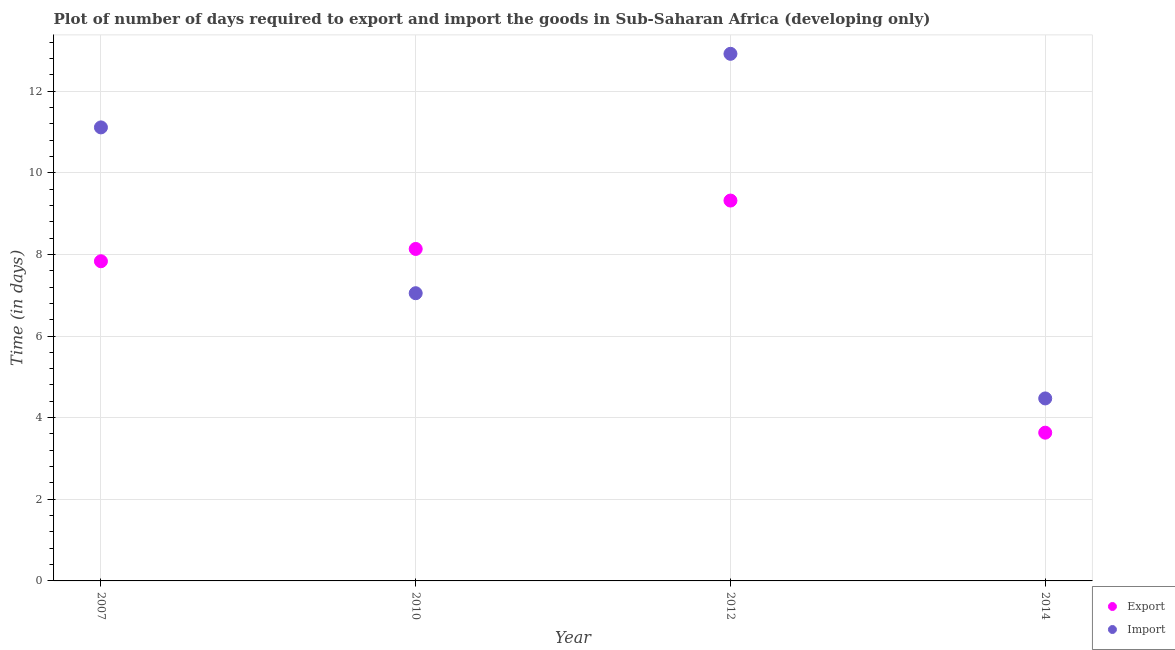Is the number of dotlines equal to the number of legend labels?
Ensure brevity in your answer.  Yes. What is the time required to import in 2007?
Ensure brevity in your answer.  11.11. Across all years, what is the maximum time required to export?
Your response must be concise. 9.32. Across all years, what is the minimum time required to export?
Give a very brief answer. 3.63. In which year was the time required to export minimum?
Make the answer very short. 2014. What is the total time required to export in the graph?
Make the answer very short. 28.91. What is the difference between the time required to import in 2012 and that in 2014?
Provide a short and direct response. 8.44. What is the difference between the time required to import in 2014 and the time required to export in 2012?
Give a very brief answer. -4.85. What is the average time required to import per year?
Offer a very short reply. 8.89. In the year 2012, what is the difference between the time required to import and time required to export?
Provide a succinct answer. 3.59. What is the ratio of the time required to export in 2010 to that in 2012?
Make the answer very short. 0.87. Is the time required to import in 2007 less than that in 2014?
Ensure brevity in your answer.  No. What is the difference between the highest and the second highest time required to import?
Offer a very short reply. 1.8. What is the difference between the highest and the lowest time required to import?
Ensure brevity in your answer.  8.44. Is the time required to import strictly greater than the time required to export over the years?
Offer a terse response. No. How many dotlines are there?
Provide a succinct answer. 2. How many years are there in the graph?
Your response must be concise. 4. Are the values on the major ticks of Y-axis written in scientific E-notation?
Offer a terse response. No. Does the graph contain any zero values?
Keep it short and to the point. No. How many legend labels are there?
Give a very brief answer. 2. What is the title of the graph?
Your answer should be very brief. Plot of number of days required to export and import the goods in Sub-Saharan Africa (developing only). Does "Unregistered firms" appear as one of the legend labels in the graph?
Make the answer very short. No. What is the label or title of the Y-axis?
Your response must be concise. Time (in days). What is the Time (in days) of Export in 2007?
Your answer should be very brief. 7.83. What is the Time (in days) of Import in 2007?
Make the answer very short. 11.11. What is the Time (in days) of Export in 2010?
Offer a terse response. 8.13. What is the Time (in days) of Import in 2010?
Provide a short and direct response. 7.05. What is the Time (in days) of Export in 2012?
Keep it short and to the point. 9.32. What is the Time (in days) of Import in 2012?
Give a very brief answer. 12.91. What is the Time (in days) in Export in 2014?
Make the answer very short. 3.63. What is the Time (in days) in Import in 2014?
Your response must be concise. 4.47. Across all years, what is the maximum Time (in days) of Export?
Your answer should be compact. 9.32. Across all years, what is the maximum Time (in days) of Import?
Offer a very short reply. 12.91. Across all years, what is the minimum Time (in days) in Export?
Provide a short and direct response. 3.63. Across all years, what is the minimum Time (in days) in Import?
Provide a succinct answer. 4.47. What is the total Time (in days) in Export in the graph?
Offer a terse response. 28.91. What is the total Time (in days) of Import in the graph?
Ensure brevity in your answer.  35.54. What is the difference between the Time (in days) in Export in 2007 and that in 2010?
Keep it short and to the point. -0.3. What is the difference between the Time (in days) of Import in 2007 and that in 2010?
Your answer should be compact. 4.06. What is the difference between the Time (in days) of Export in 2007 and that in 2012?
Provide a succinct answer. -1.49. What is the difference between the Time (in days) of Import in 2007 and that in 2012?
Make the answer very short. -1.8. What is the difference between the Time (in days) of Import in 2007 and that in 2014?
Keep it short and to the point. 6.64. What is the difference between the Time (in days) of Export in 2010 and that in 2012?
Make the answer very short. -1.19. What is the difference between the Time (in days) in Import in 2010 and that in 2012?
Offer a terse response. -5.86. What is the difference between the Time (in days) in Export in 2010 and that in 2014?
Give a very brief answer. 4.5. What is the difference between the Time (in days) of Import in 2010 and that in 2014?
Make the answer very short. 2.58. What is the difference between the Time (in days) in Export in 2012 and that in 2014?
Your answer should be very brief. 5.69. What is the difference between the Time (in days) in Import in 2012 and that in 2014?
Your response must be concise. 8.44. What is the difference between the Time (in days) of Export in 2007 and the Time (in days) of Import in 2010?
Give a very brief answer. 0.78. What is the difference between the Time (in days) of Export in 2007 and the Time (in days) of Import in 2012?
Your answer should be compact. -5.08. What is the difference between the Time (in days) of Export in 2007 and the Time (in days) of Import in 2014?
Offer a terse response. 3.36. What is the difference between the Time (in days) in Export in 2010 and the Time (in days) in Import in 2012?
Your response must be concise. -4.78. What is the difference between the Time (in days) in Export in 2010 and the Time (in days) in Import in 2014?
Offer a terse response. 3.66. What is the difference between the Time (in days) in Export in 2012 and the Time (in days) in Import in 2014?
Offer a terse response. 4.85. What is the average Time (in days) of Export per year?
Keep it short and to the point. 7.23. What is the average Time (in days) in Import per year?
Your answer should be very brief. 8.89. In the year 2007, what is the difference between the Time (in days) of Export and Time (in days) of Import?
Your answer should be compact. -3.28. In the year 2010, what is the difference between the Time (in days) of Export and Time (in days) of Import?
Provide a succinct answer. 1.08. In the year 2012, what is the difference between the Time (in days) in Export and Time (in days) in Import?
Offer a terse response. -3.59. In the year 2014, what is the difference between the Time (in days) in Export and Time (in days) in Import?
Ensure brevity in your answer.  -0.84. What is the ratio of the Time (in days) of Export in 2007 to that in 2010?
Offer a terse response. 0.96. What is the ratio of the Time (in days) of Import in 2007 to that in 2010?
Make the answer very short. 1.58. What is the ratio of the Time (in days) in Export in 2007 to that in 2012?
Your response must be concise. 0.84. What is the ratio of the Time (in days) of Import in 2007 to that in 2012?
Your answer should be very brief. 0.86. What is the ratio of the Time (in days) in Export in 2007 to that in 2014?
Offer a terse response. 2.16. What is the ratio of the Time (in days) of Import in 2007 to that in 2014?
Keep it short and to the point. 2.49. What is the ratio of the Time (in days) in Export in 2010 to that in 2012?
Ensure brevity in your answer.  0.87. What is the ratio of the Time (in days) in Import in 2010 to that in 2012?
Provide a succinct answer. 0.55. What is the ratio of the Time (in days) in Export in 2010 to that in 2014?
Provide a succinct answer. 2.24. What is the ratio of the Time (in days) in Import in 2010 to that in 2014?
Ensure brevity in your answer.  1.58. What is the ratio of the Time (in days) of Export in 2012 to that in 2014?
Give a very brief answer. 2.57. What is the ratio of the Time (in days) of Import in 2012 to that in 2014?
Your answer should be compact. 2.89. What is the difference between the highest and the second highest Time (in days) in Export?
Offer a very short reply. 1.19. What is the difference between the highest and the second highest Time (in days) in Import?
Give a very brief answer. 1.8. What is the difference between the highest and the lowest Time (in days) in Export?
Offer a very short reply. 5.69. What is the difference between the highest and the lowest Time (in days) in Import?
Your answer should be very brief. 8.44. 